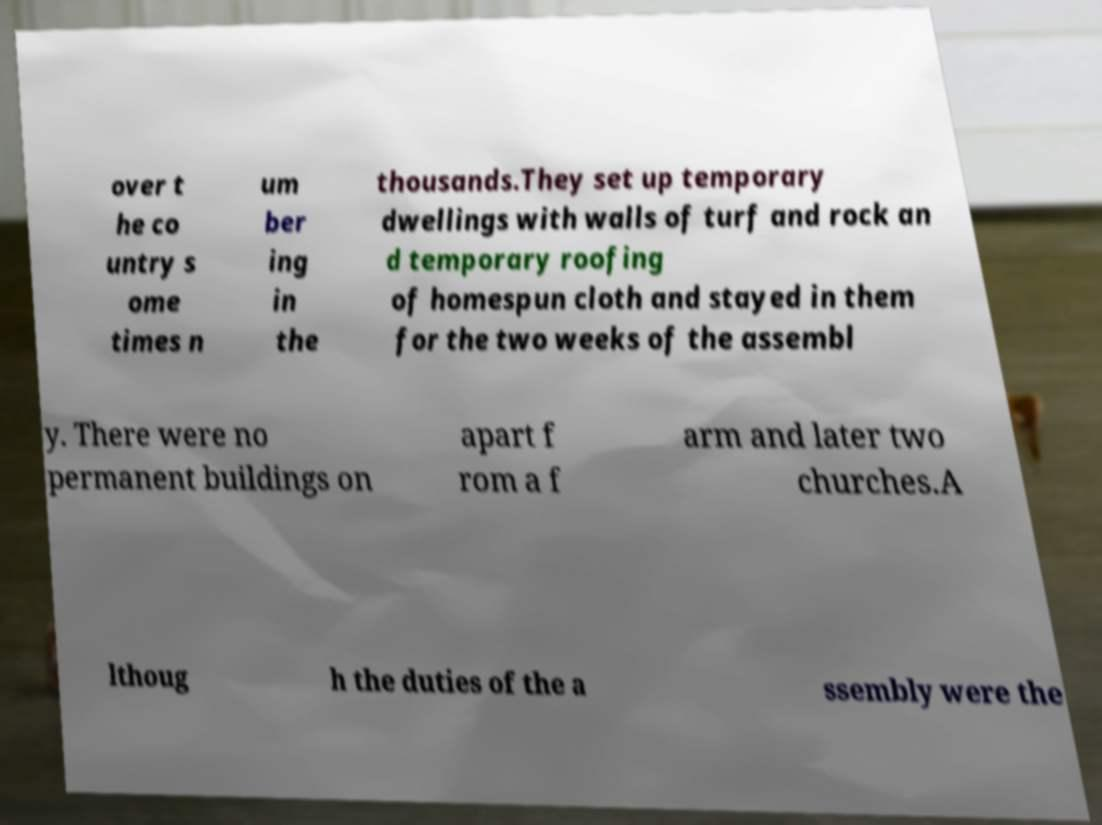What messages or text are displayed in this image? I need them in a readable, typed format. over t he co untry s ome times n um ber ing in the thousands.They set up temporary dwellings with walls of turf and rock an d temporary roofing of homespun cloth and stayed in them for the two weeks of the assembl y. There were no permanent buildings on apart f rom a f arm and later two churches.A lthoug h the duties of the a ssembly were the 